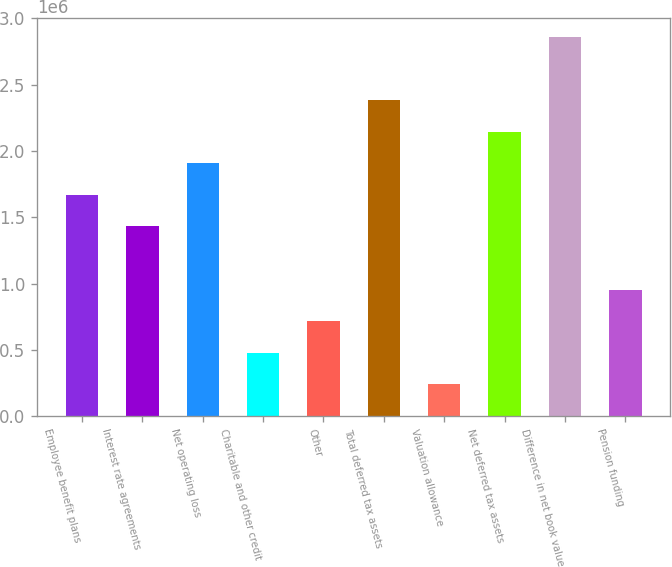Convert chart to OTSL. <chart><loc_0><loc_0><loc_500><loc_500><bar_chart><fcel>Employee benefit plans<fcel>Interest rate agreements<fcel>Net operating loss<fcel>Charitable and other credit<fcel>Other<fcel>Total deferred tax assets<fcel>Valuation allowance<fcel>Net deferred tax assets<fcel>Difference in net book value<fcel>Pension funding<nl><fcel>1.6686e+06<fcel>1.43036e+06<fcel>1.90685e+06<fcel>477359<fcel>715608<fcel>2.38335e+06<fcel>239110<fcel>2.1451e+06<fcel>2.85985e+06<fcel>953857<nl></chart> 